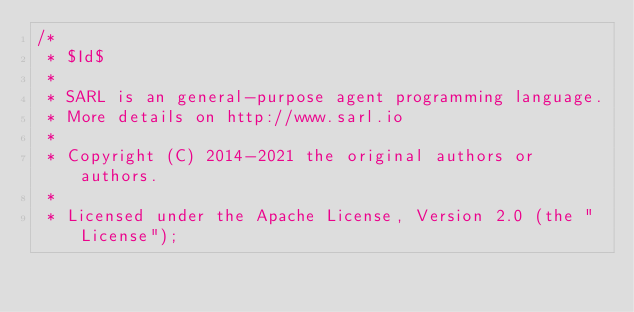<code> <loc_0><loc_0><loc_500><loc_500><_Java_>/*
 * $Id$
 *
 * SARL is an general-purpose agent programming language.
 * More details on http://www.sarl.io
 *
 * Copyright (C) 2014-2021 the original authors or authors.
 *
 * Licensed under the Apache License, Version 2.0 (the "License");</code> 